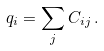<formula> <loc_0><loc_0><loc_500><loc_500>q _ { i } = \sum _ { j } C _ { i j } \, .</formula> 